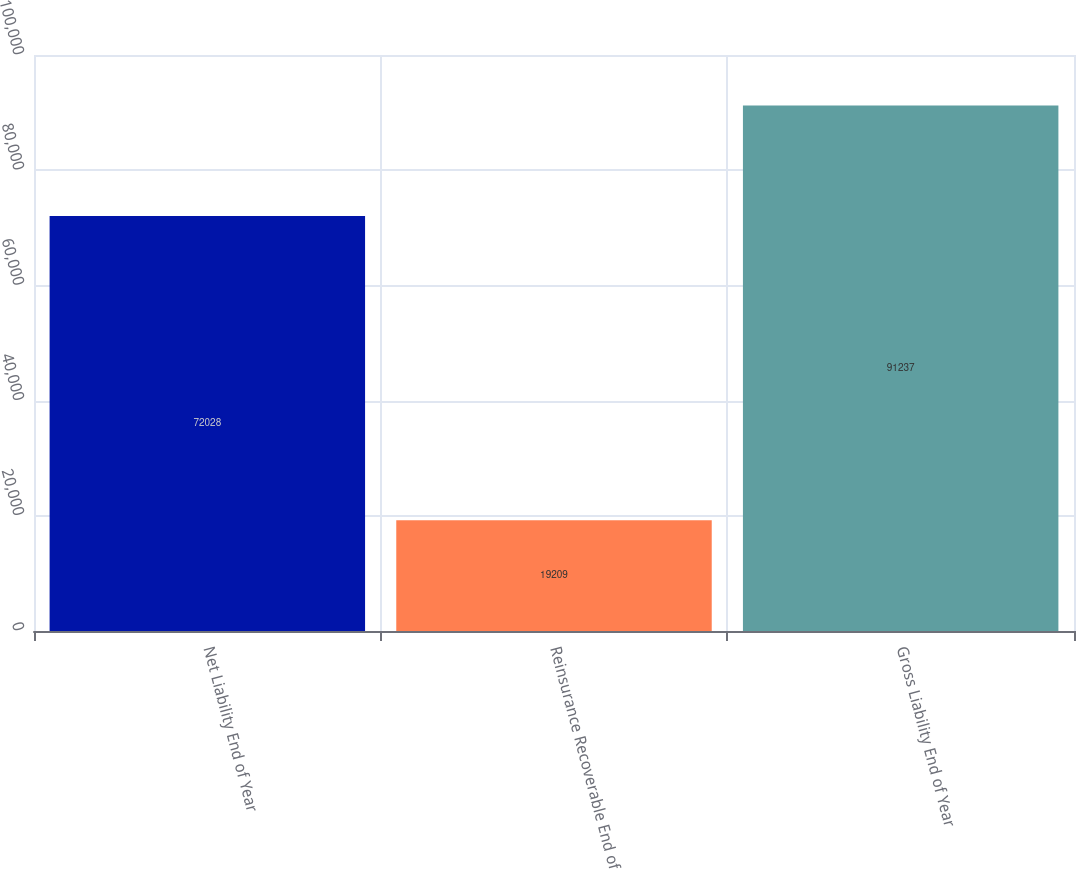<chart> <loc_0><loc_0><loc_500><loc_500><bar_chart><fcel>Net Liability End of Year<fcel>Reinsurance Recoverable End of<fcel>Gross Liability End of Year<nl><fcel>72028<fcel>19209<fcel>91237<nl></chart> 